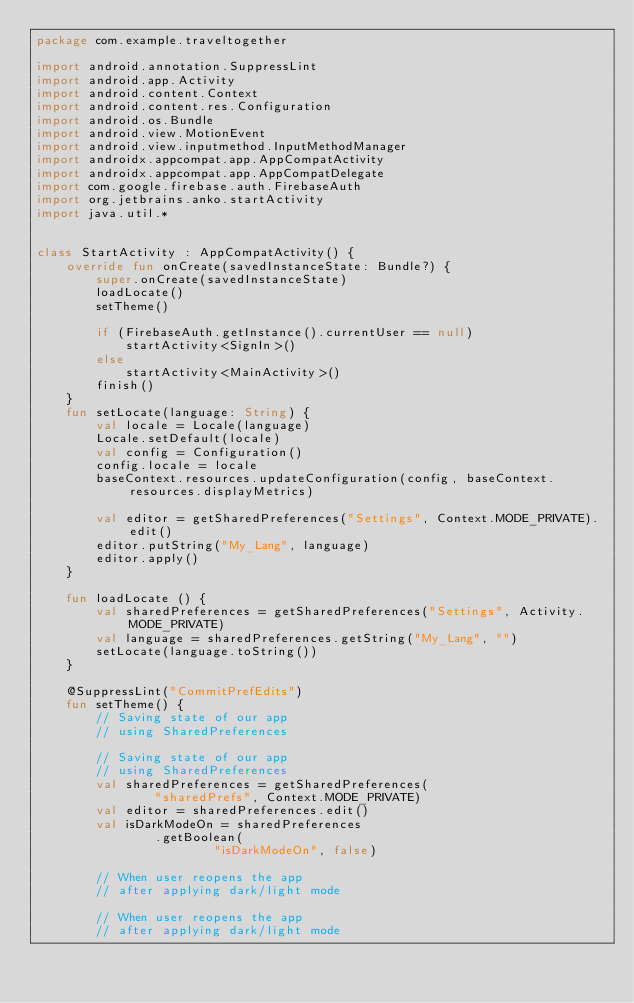Convert code to text. <code><loc_0><loc_0><loc_500><loc_500><_Kotlin_>package com.example.traveltogether

import android.annotation.SuppressLint
import android.app.Activity
import android.content.Context
import android.content.res.Configuration
import android.os.Bundle
import android.view.MotionEvent
import android.view.inputmethod.InputMethodManager
import androidx.appcompat.app.AppCompatActivity
import androidx.appcompat.app.AppCompatDelegate
import com.google.firebase.auth.FirebaseAuth
import org.jetbrains.anko.startActivity
import java.util.*


class StartActivity : AppCompatActivity() {
    override fun onCreate(savedInstanceState: Bundle?) {
        super.onCreate(savedInstanceState)
        loadLocate()
        setTheme()

        if (FirebaseAuth.getInstance().currentUser == null)
            startActivity<SignIn>()
        else
            startActivity<MainActivity>()
        finish()
    }
    fun setLocate(language: String) {
        val locale = Locale(language)
        Locale.setDefault(locale)
        val config = Configuration()
        config.locale = locale
        baseContext.resources.updateConfiguration(config, baseContext.resources.displayMetrics)

        val editor = getSharedPreferences("Settings", Context.MODE_PRIVATE).edit()
        editor.putString("My_Lang", language)
        editor.apply()
    }

    fun loadLocate () {
        val sharedPreferences = getSharedPreferences("Settings", Activity.MODE_PRIVATE)
        val language = sharedPreferences.getString("My_Lang", "")
        setLocate(language.toString())
    }

    @SuppressLint("CommitPrefEdits")
    fun setTheme() {
        // Saving state of our app
        // using SharedPreferences

        // Saving state of our app
        // using SharedPreferences
        val sharedPreferences = getSharedPreferences(
                "sharedPrefs", Context.MODE_PRIVATE)
        val editor = sharedPreferences.edit()
        val isDarkModeOn = sharedPreferences
                .getBoolean(
                        "isDarkModeOn", false)

        // When user reopens the app
        // after applying dark/light mode

        // When user reopens the app
        // after applying dark/light mode</code> 